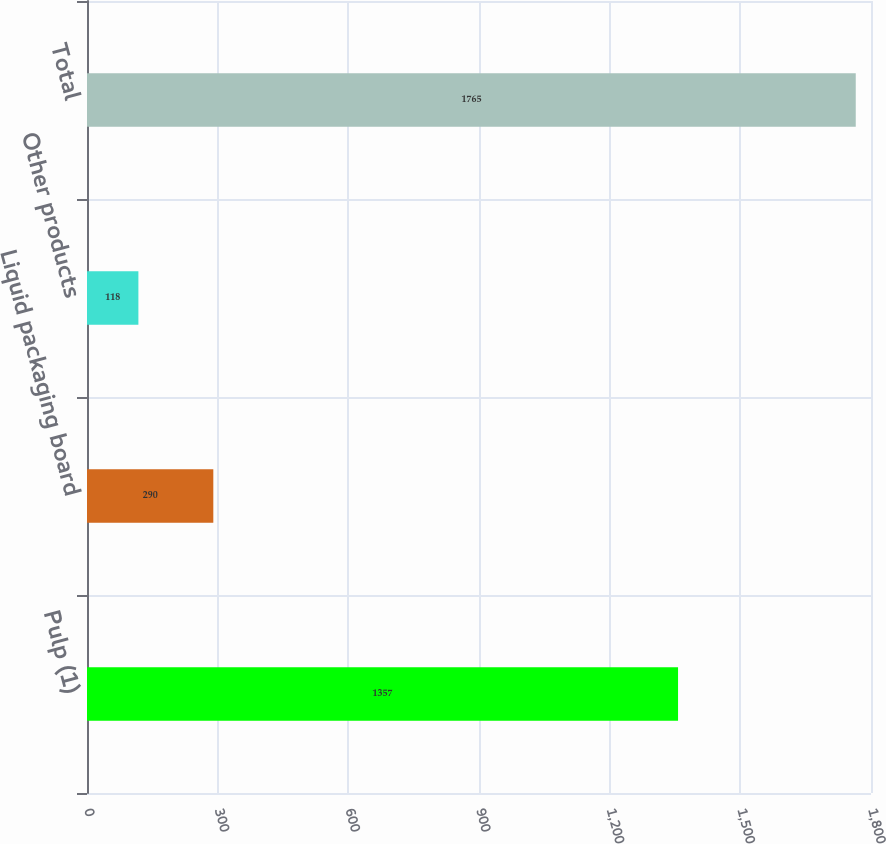Convert chart. <chart><loc_0><loc_0><loc_500><loc_500><bar_chart><fcel>Pulp (1)<fcel>Liquid packaging board<fcel>Other products<fcel>Total<nl><fcel>1357<fcel>290<fcel>118<fcel>1765<nl></chart> 